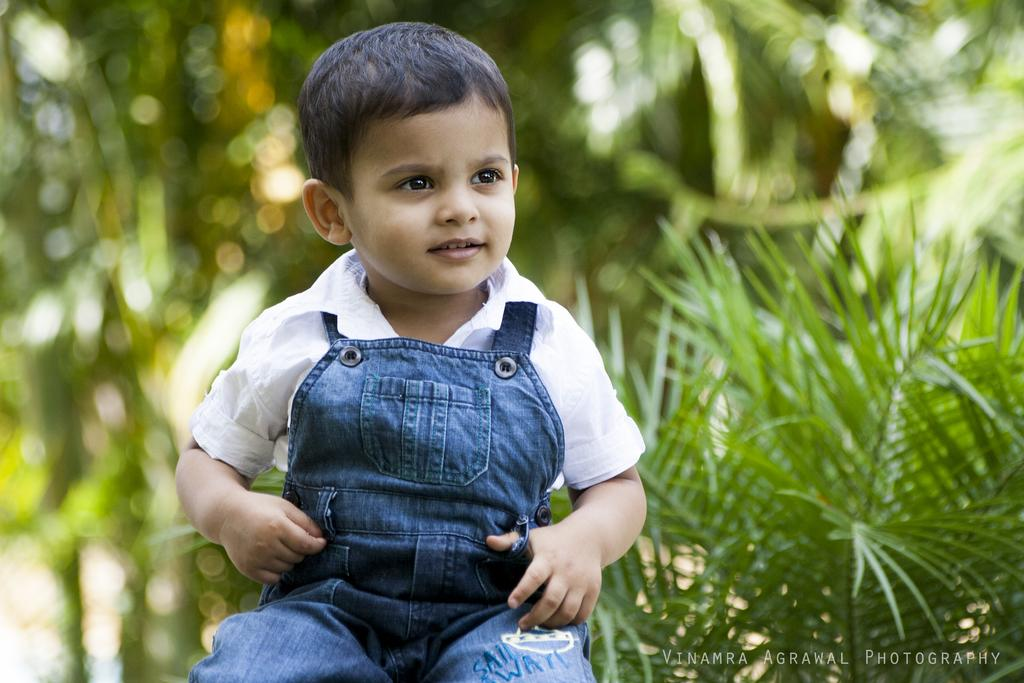What is the child doing in the image? The child is sitting and smiling in the image. Which direction is the child looking? The child is looking towards the right side. What can be seen in the background of the image? There are plants in the background of the image. What is present in the bottom right corner of the image? There is edited text in the bottom right corner of the image. What type of fruit is the child holding in the image? There is no fruit present in the image; the child is simply sitting and smiling. What is the child using to store the jar in the image? There is no jar present in the image. 